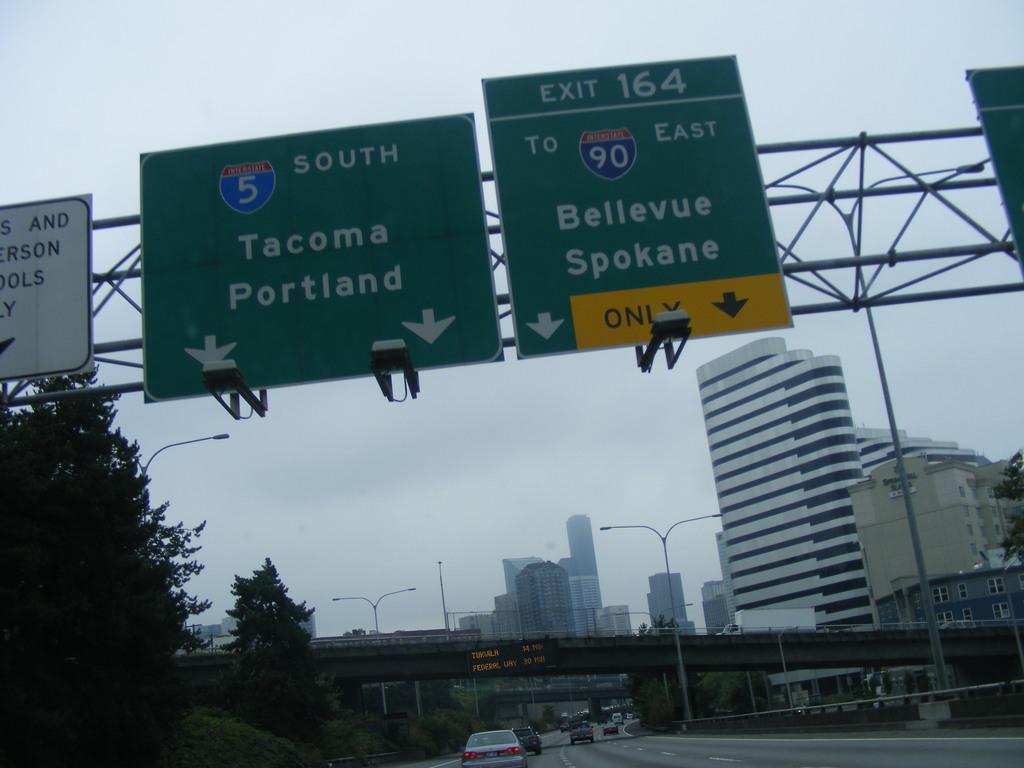Do either of the lanes lead to portland?
Ensure brevity in your answer.  Yes. 